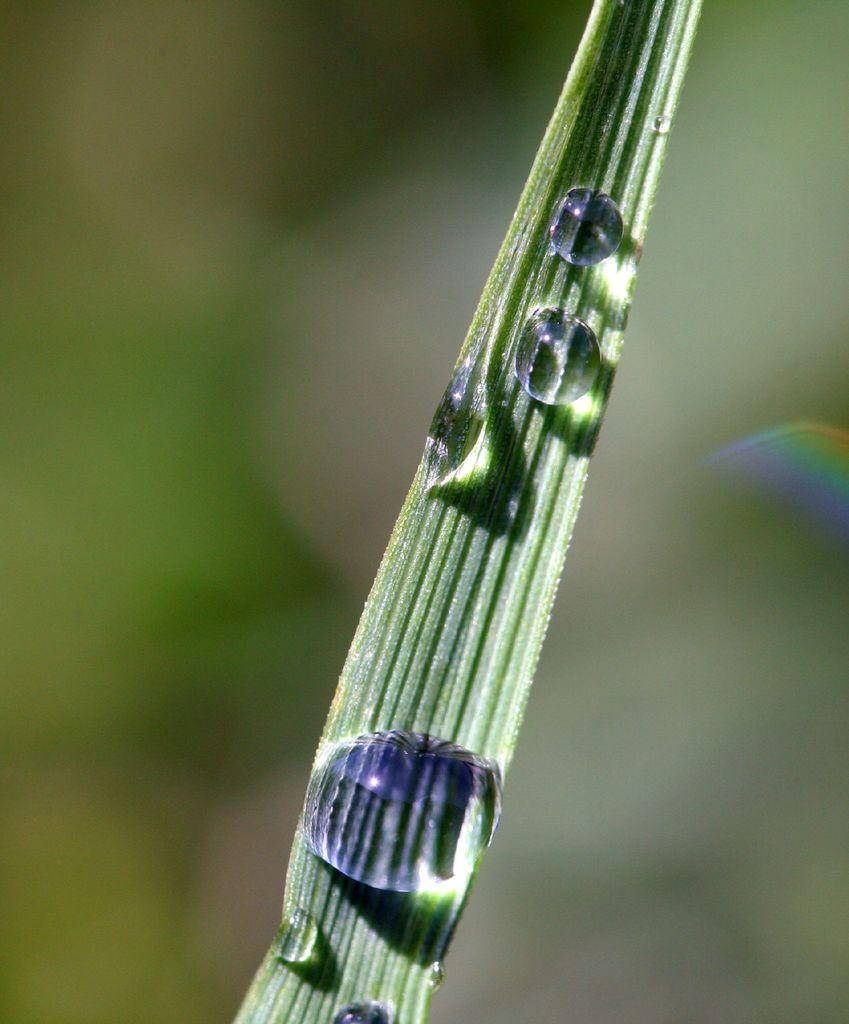What is present on the leaf in the image? There are droplets of water on a leaf in the image. Can you describe the appearance of the droplets? The droplets appear to be small and round, clinging to the surface of the leaf. What might have caused the droplets to form on the leaf? The droplets could have formed due to recent rain, dew, or condensation. What type of smoke can be seen rising from the leaf in the image? There is no smoke present in the image; it features droplets of water on a leaf. 